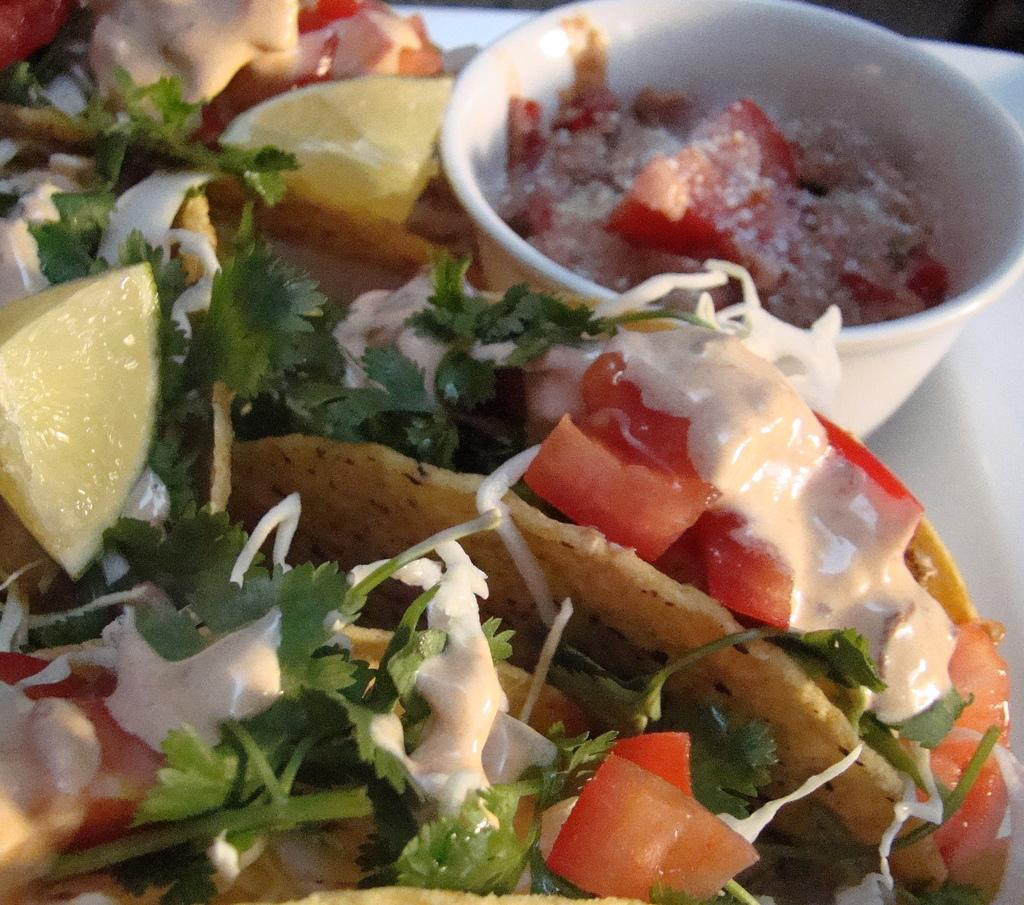What is present on the plate in the image? There are food items on the plate in the image. What else can be seen in the image besides the plate? There is a bowl in the image. What is inside the bowl? There is food in the bowl. What type of rod can be seen supporting the body in the image? There is no rod or body present in the image; it only features a plate with food items and a bowl with food. 